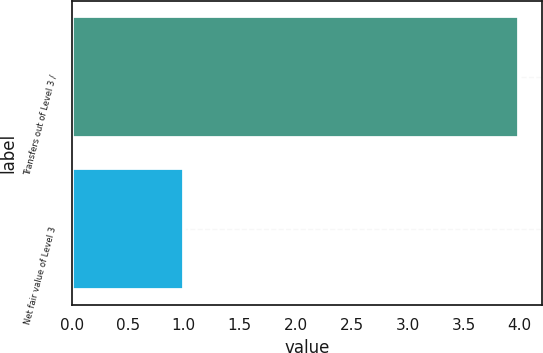<chart> <loc_0><loc_0><loc_500><loc_500><bar_chart><fcel>Transfers out of Level 3 /<fcel>Net fair value of Level 3<nl><fcel>4<fcel>1<nl></chart> 